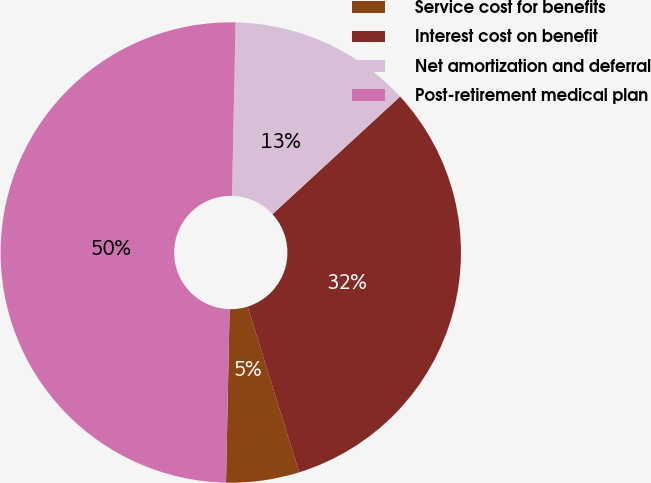Convert chart to OTSL. <chart><loc_0><loc_0><loc_500><loc_500><pie_chart><fcel>Service cost for benefits<fcel>Interest cost on benefit<fcel>Net amortization and deferral<fcel>Post-retirement medical plan<nl><fcel>5.13%<fcel>32.05%<fcel>12.82%<fcel>50.0%<nl></chart> 